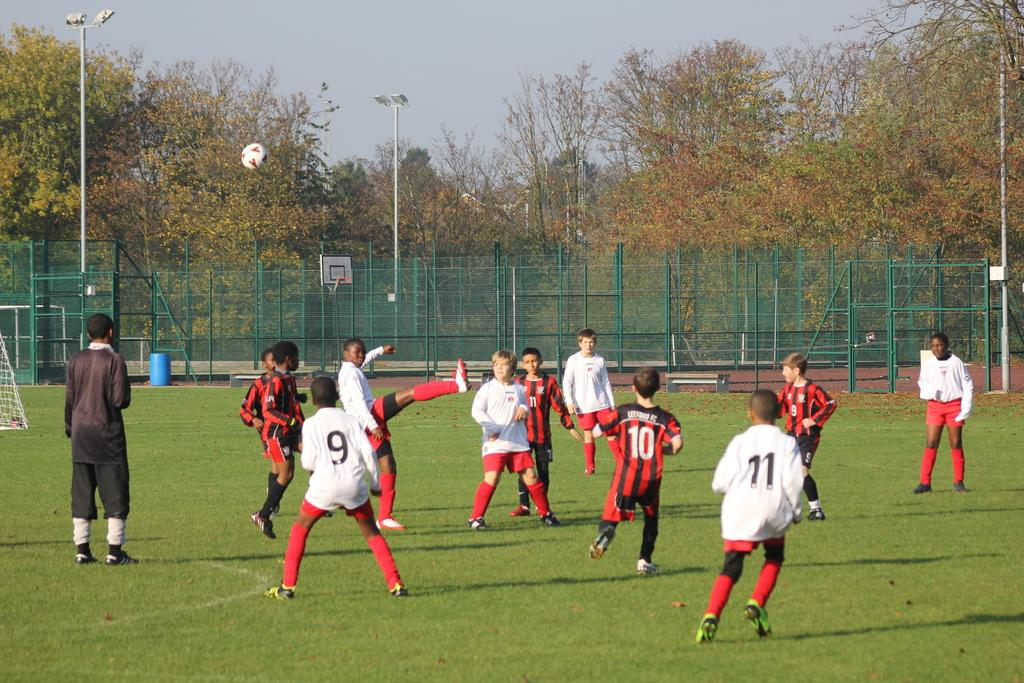<image>
Provide a brief description of the given image. Number 9 on a children's sports team has their back to the camera. 